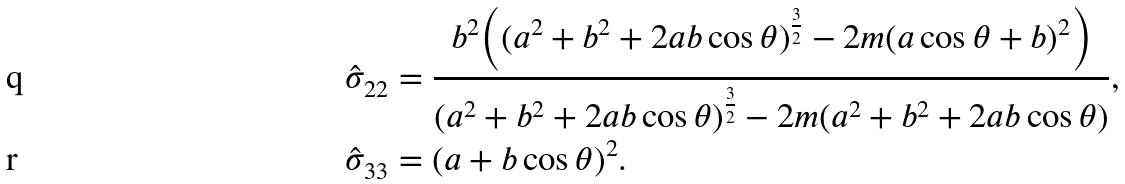<formula> <loc_0><loc_0><loc_500><loc_500>\hat { \sigma } _ { 2 2 } & = \frac { b ^ { 2 } \Big { ( } ( a ^ { 2 } + b ^ { 2 } + 2 a b \cos \theta ) ^ { \frac { 3 } { 2 } } - 2 m ( a \cos \theta + b ) ^ { 2 } \Big { ) } } { ( a ^ { 2 } + b ^ { 2 } + 2 a b \cos \theta ) ^ { \frac { 3 } { 2 } } - 2 m ( a ^ { 2 } + b ^ { 2 } + 2 a b \cos \theta ) } , \\ \hat { \sigma } _ { 3 3 } & = ( a + b \cos \theta ) ^ { 2 } .</formula> 